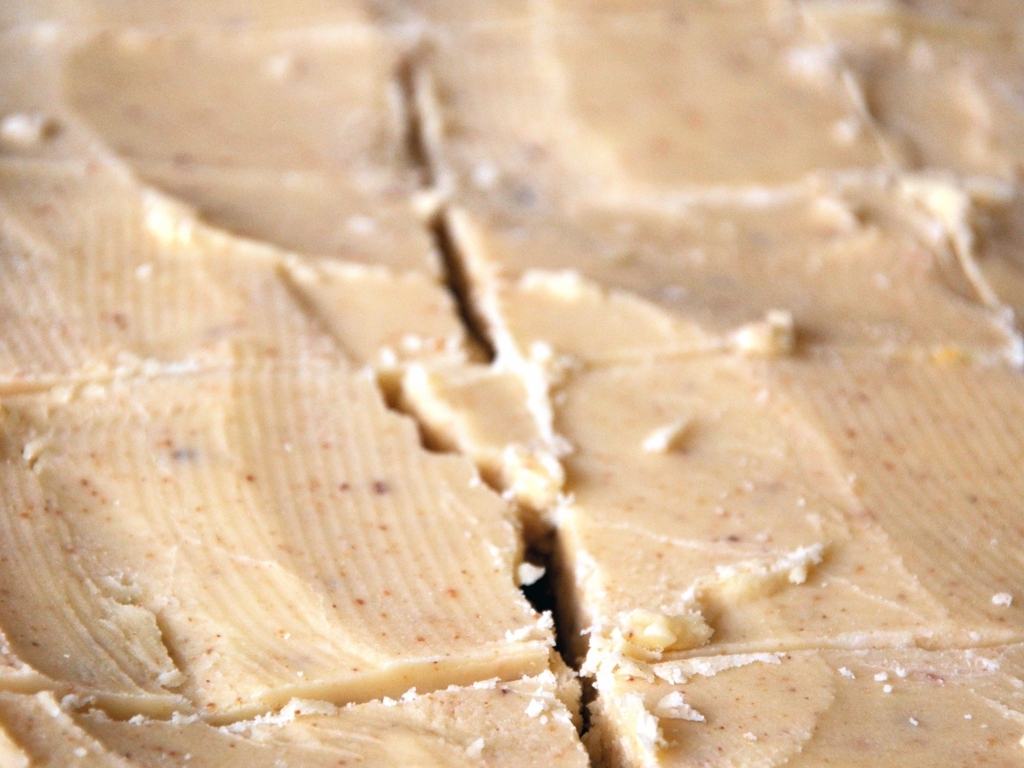How can the quality of this image be improved? To improve the quality of the image, one could use a higher resolution camera to capture more detail, adjust the lighting to avoid overexposure, and ensure the camera focus is sharp to enhance the clarity and texture of the subject. 